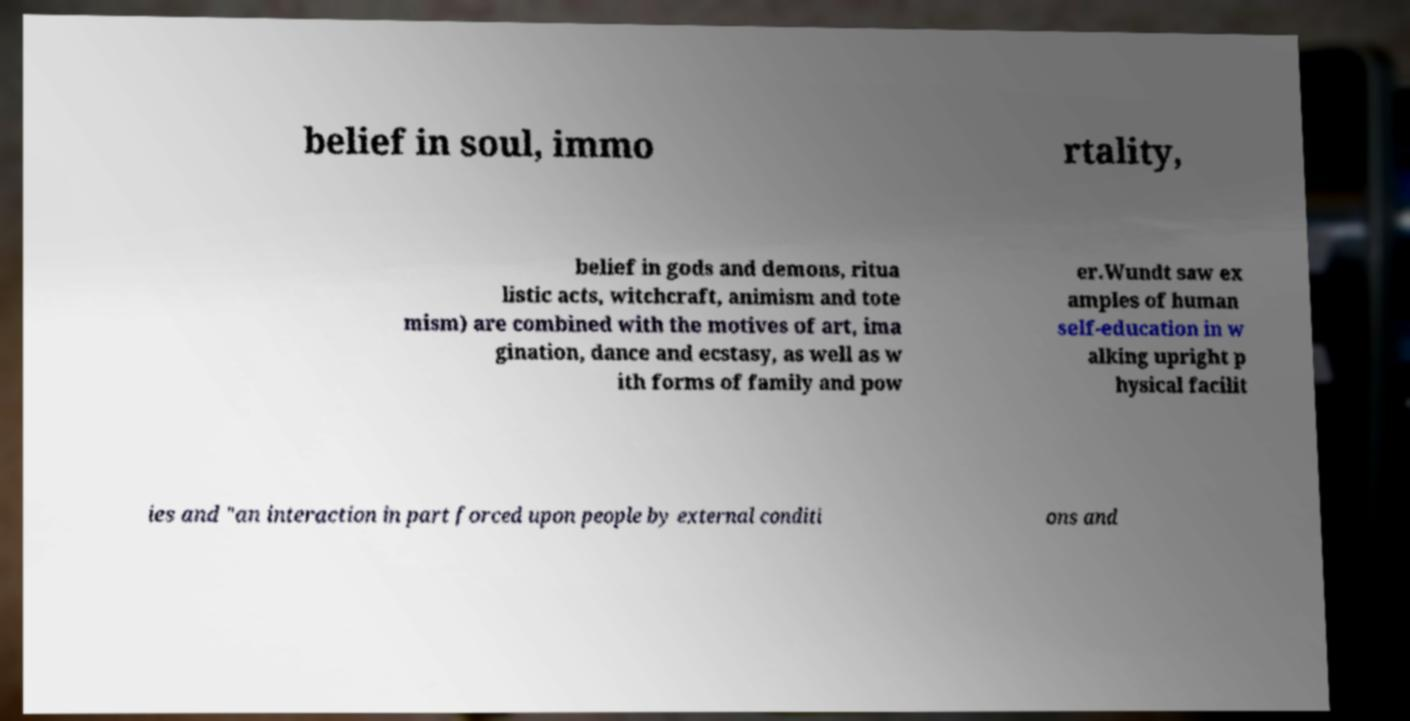Can you accurately transcribe the text from the provided image for me? belief in soul, immo rtality, belief in gods and demons, ritua listic acts, witchcraft, animism and tote mism) are combined with the motives of art, ima gination, dance and ecstasy, as well as w ith forms of family and pow er.Wundt saw ex amples of human self-education in w alking upright p hysical facilit ies and "an interaction in part forced upon people by external conditi ons and 